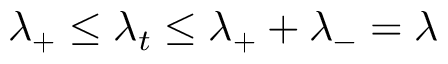Convert formula to latex. <formula><loc_0><loc_0><loc_500><loc_500>\lambda _ { + } \leq \lambda _ { t } \leq \lambda _ { + } + \lambda _ { - } = \lambda</formula> 